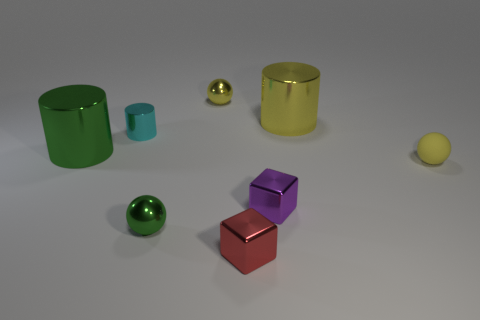Subtract all small yellow shiny balls. How many balls are left? 2 Subtract all yellow blocks. How many yellow balls are left? 2 Subtract all green balls. How many balls are left? 2 Add 2 small purple cubes. How many objects exist? 10 Subtract all cylinders. How many objects are left? 5 Subtract all red cubes. Subtract all brown spheres. How many cubes are left? 1 Subtract all tiny red matte cylinders. Subtract all matte spheres. How many objects are left? 7 Add 8 yellow shiny balls. How many yellow shiny balls are left? 9 Add 1 purple cubes. How many purple cubes exist? 2 Subtract 1 green cylinders. How many objects are left? 7 